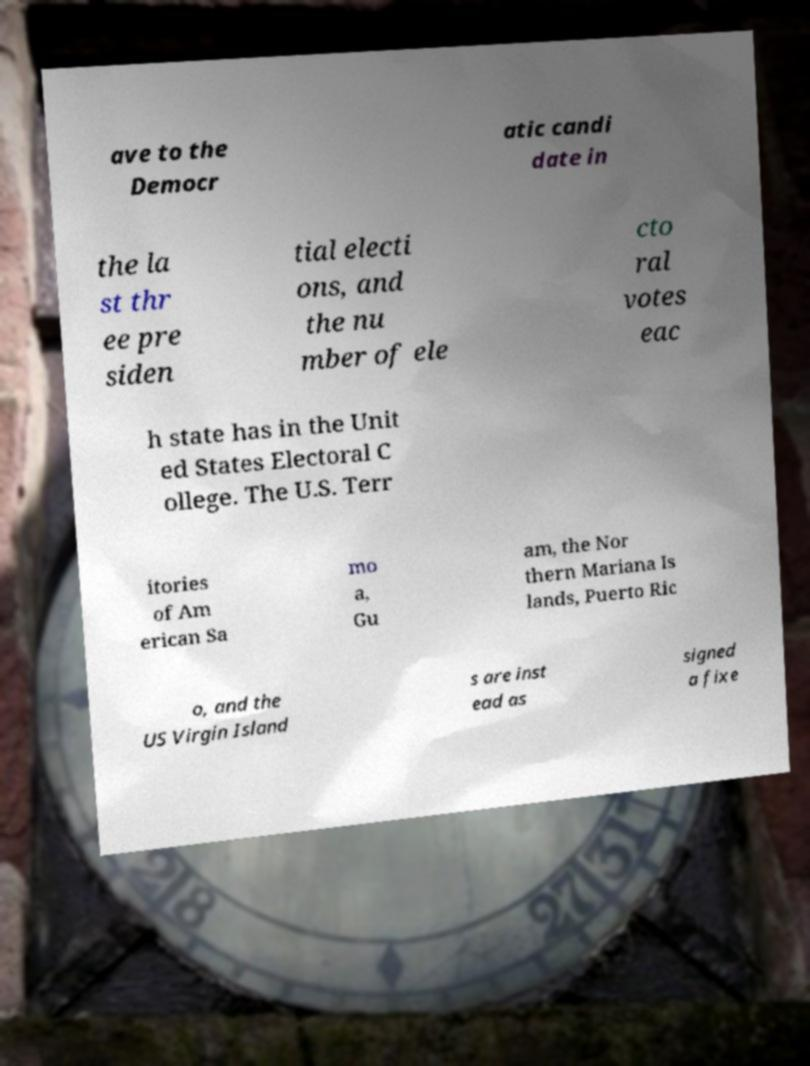Please read and relay the text visible in this image. What does it say? ave to the Democr atic candi date in the la st thr ee pre siden tial electi ons, and the nu mber of ele cto ral votes eac h state has in the Unit ed States Electoral C ollege. The U.S. Terr itories of Am erican Sa mo a, Gu am, the Nor thern Mariana Is lands, Puerto Ric o, and the US Virgin Island s are inst ead as signed a fixe 